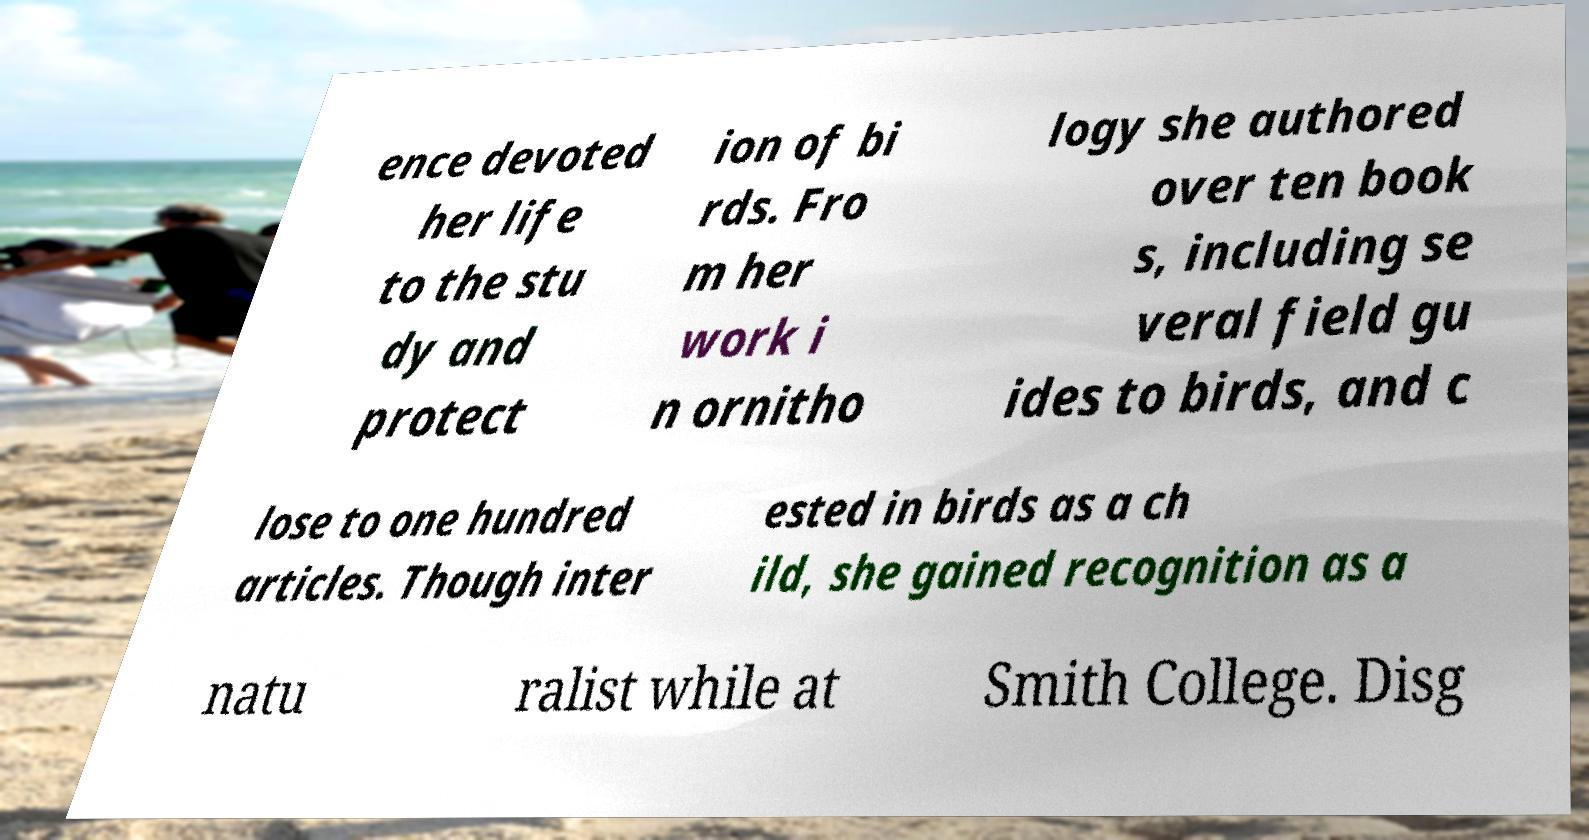Can you read and provide the text displayed in the image?This photo seems to have some interesting text. Can you extract and type it out for me? ence devoted her life to the stu dy and protect ion of bi rds. Fro m her work i n ornitho logy she authored over ten book s, including se veral field gu ides to birds, and c lose to one hundred articles. Though inter ested in birds as a ch ild, she gained recognition as a natu ralist while at Smith College. Disg 